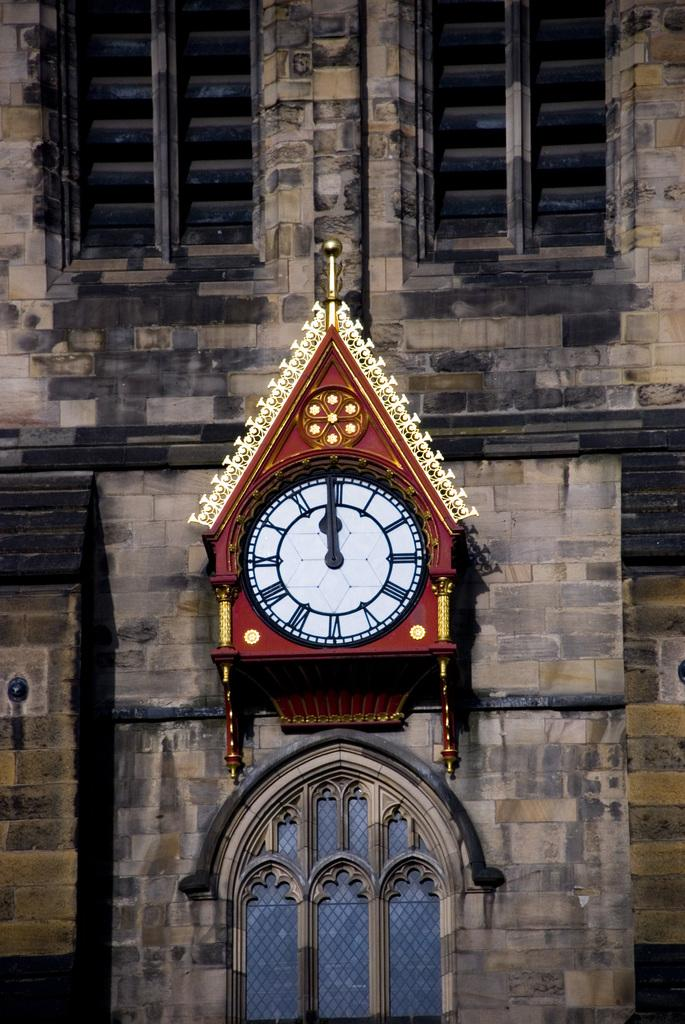<image>
Summarize the visual content of the image. A clock hanging on a brick wall shows the time as 12:00/ 